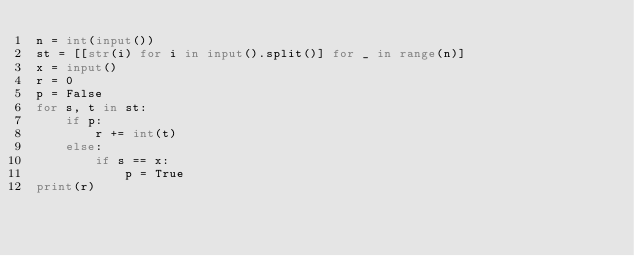<code> <loc_0><loc_0><loc_500><loc_500><_Python_>n = int(input())
st = [[str(i) for i in input().split()] for _ in range(n)]
x = input()
r = 0
p = False
for s, t in st:
    if p:
        r += int(t)
    else:
        if s == x:
            p = True
print(r)</code> 